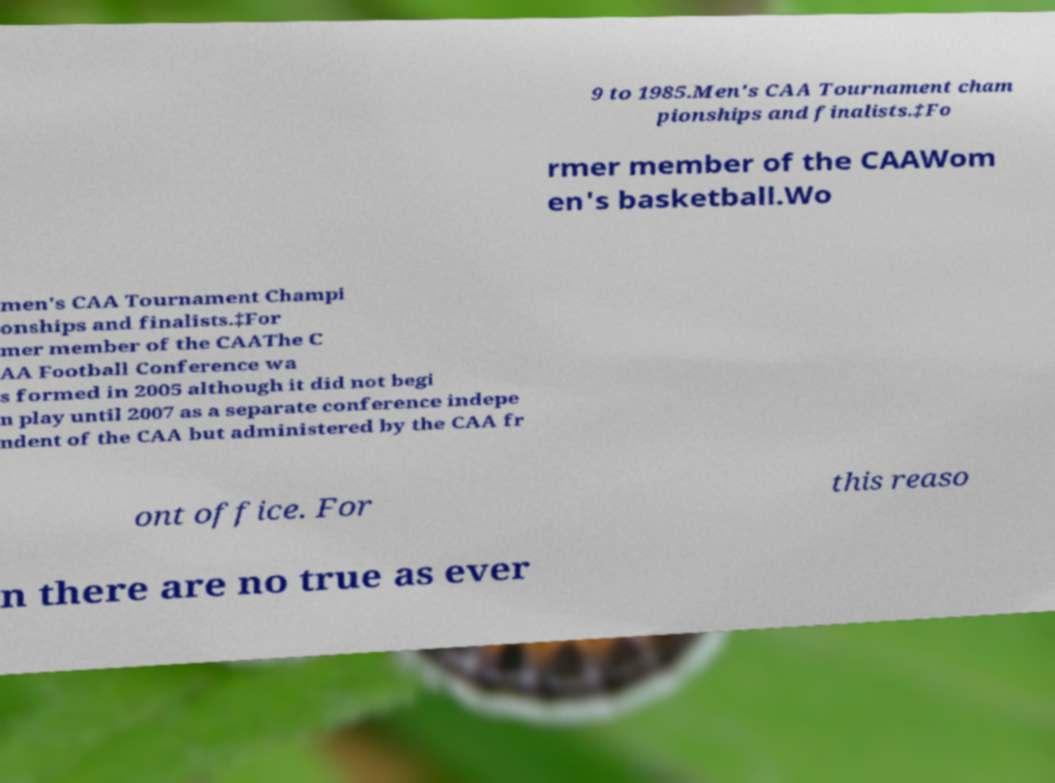Can you accurately transcribe the text from the provided image for me? 9 to 1985.Men's CAA Tournament cham pionships and finalists.‡Fo rmer member of the CAAWom en's basketball.Wo men's CAA Tournament Champi onships and finalists.‡For mer member of the CAAThe C AA Football Conference wa s formed in 2005 although it did not begi n play until 2007 as a separate conference indepe ndent of the CAA but administered by the CAA fr ont office. For this reaso n there are no true as ever 